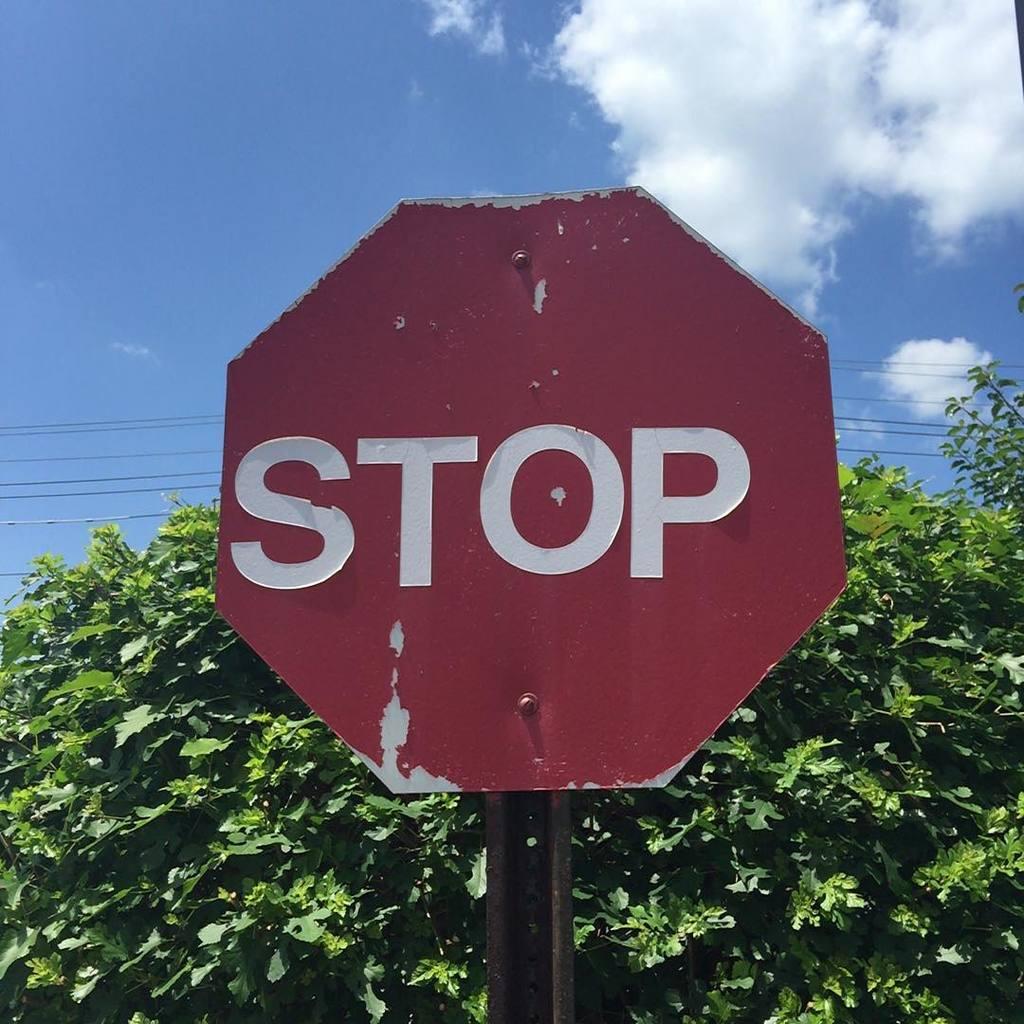What does the sign say?
Offer a very short reply. Stop. 